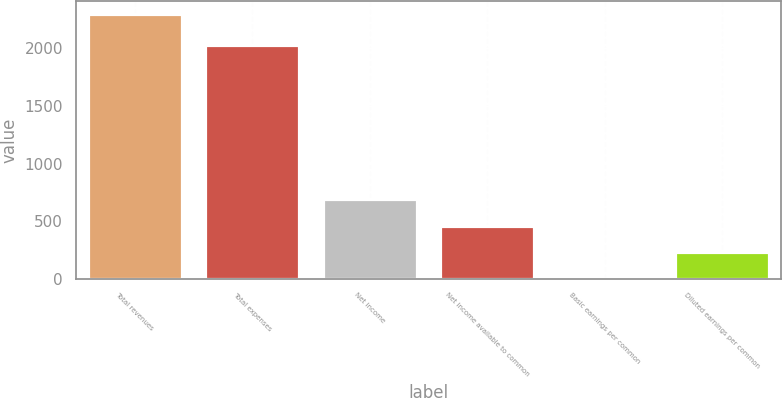Convert chart to OTSL. <chart><loc_0><loc_0><loc_500><loc_500><bar_chart><fcel>Total revenues<fcel>Total expenses<fcel>Net income<fcel>Net income available to common<fcel>Basic earnings per common<fcel>Diluted earnings per common<nl><fcel>2295.9<fcel>2030<fcel>689.3<fcel>459.78<fcel>0.74<fcel>230.26<nl></chart> 